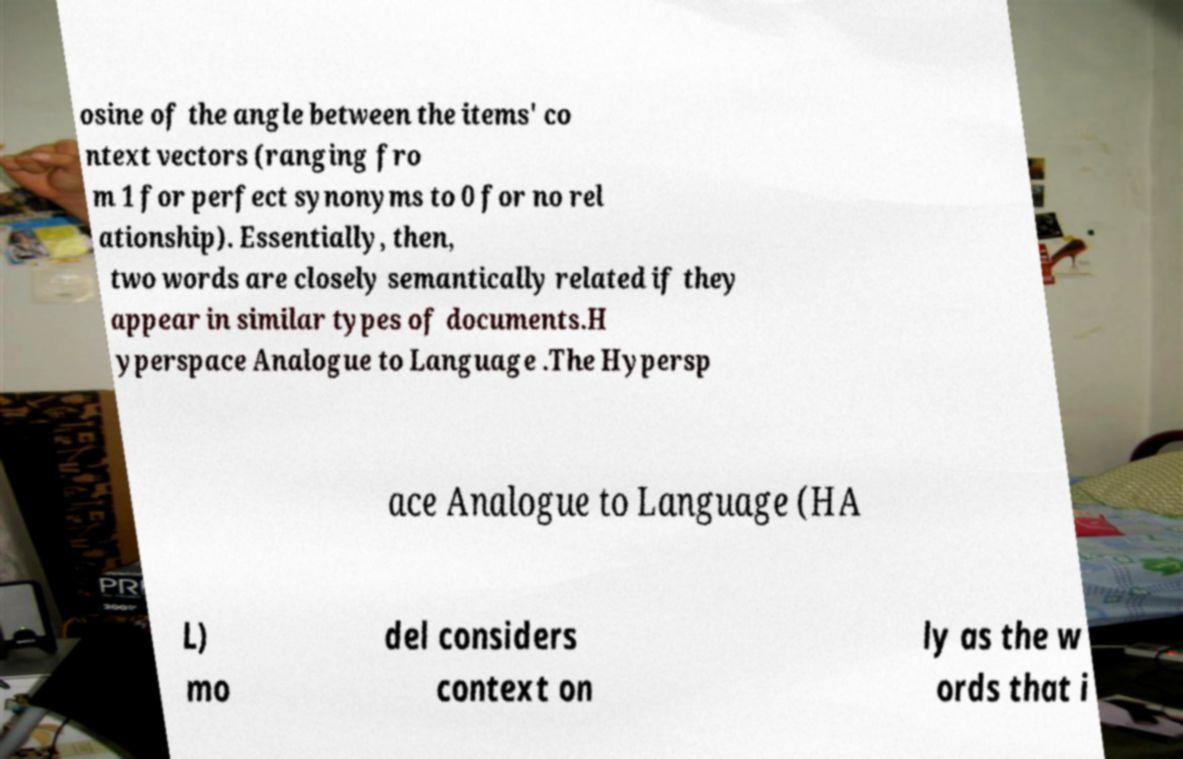Please identify and transcribe the text found in this image. osine of the angle between the items' co ntext vectors (ranging fro m 1 for perfect synonyms to 0 for no rel ationship). Essentially, then, two words are closely semantically related if they appear in similar types of documents.H yperspace Analogue to Language .The Hypersp ace Analogue to Language (HA L) mo del considers context on ly as the w ords that i 